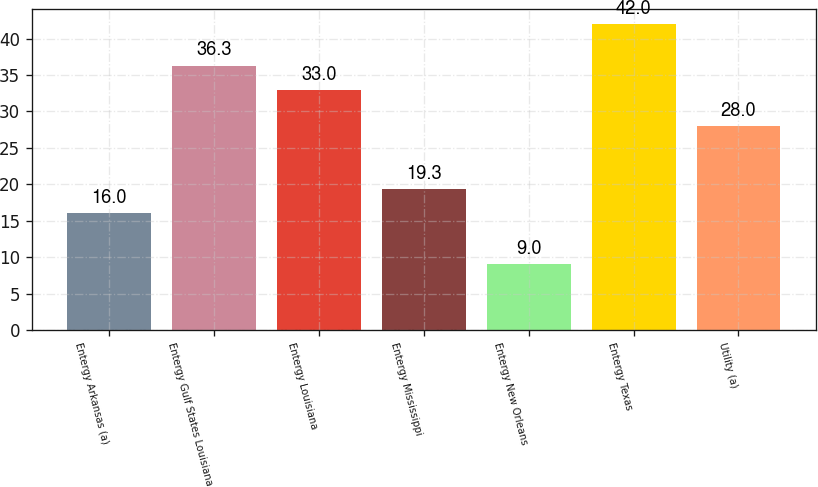Convert chart. <chart><loc_0><loc_0><loc_500><loc_500><bar_chart><fcel>Entergy Arkansas (a)<fcel>Entergy Gulf States Louisiana<fcel>Entergy Louisiana<fcel>Entergy Mississippi<fcel>Entergy New Orleans<fcel>Entergy Texas<fcel>Utility (a)<nl><fcel>16<fcel>36.3<fcel>33<fcel>19.3<fcel>9<fcel>42<fcel>28<nl></chart> 